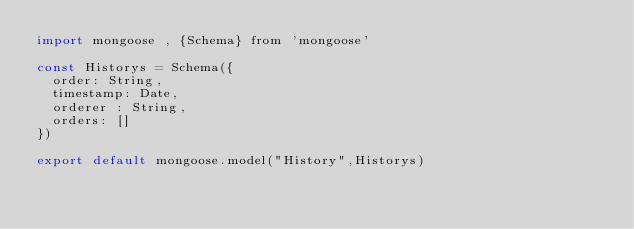Convert code to text. <code><loc_0><loc_0><loc_500><loc_500><_JavaScript_>import mongoose , {Schema} from 'mongoose'

const Historys = Schema({
  order: String,
  timestamp: Date,
  orderer : String,
  orders: []
})

export default mongoose.model("History",Historys)</code> 